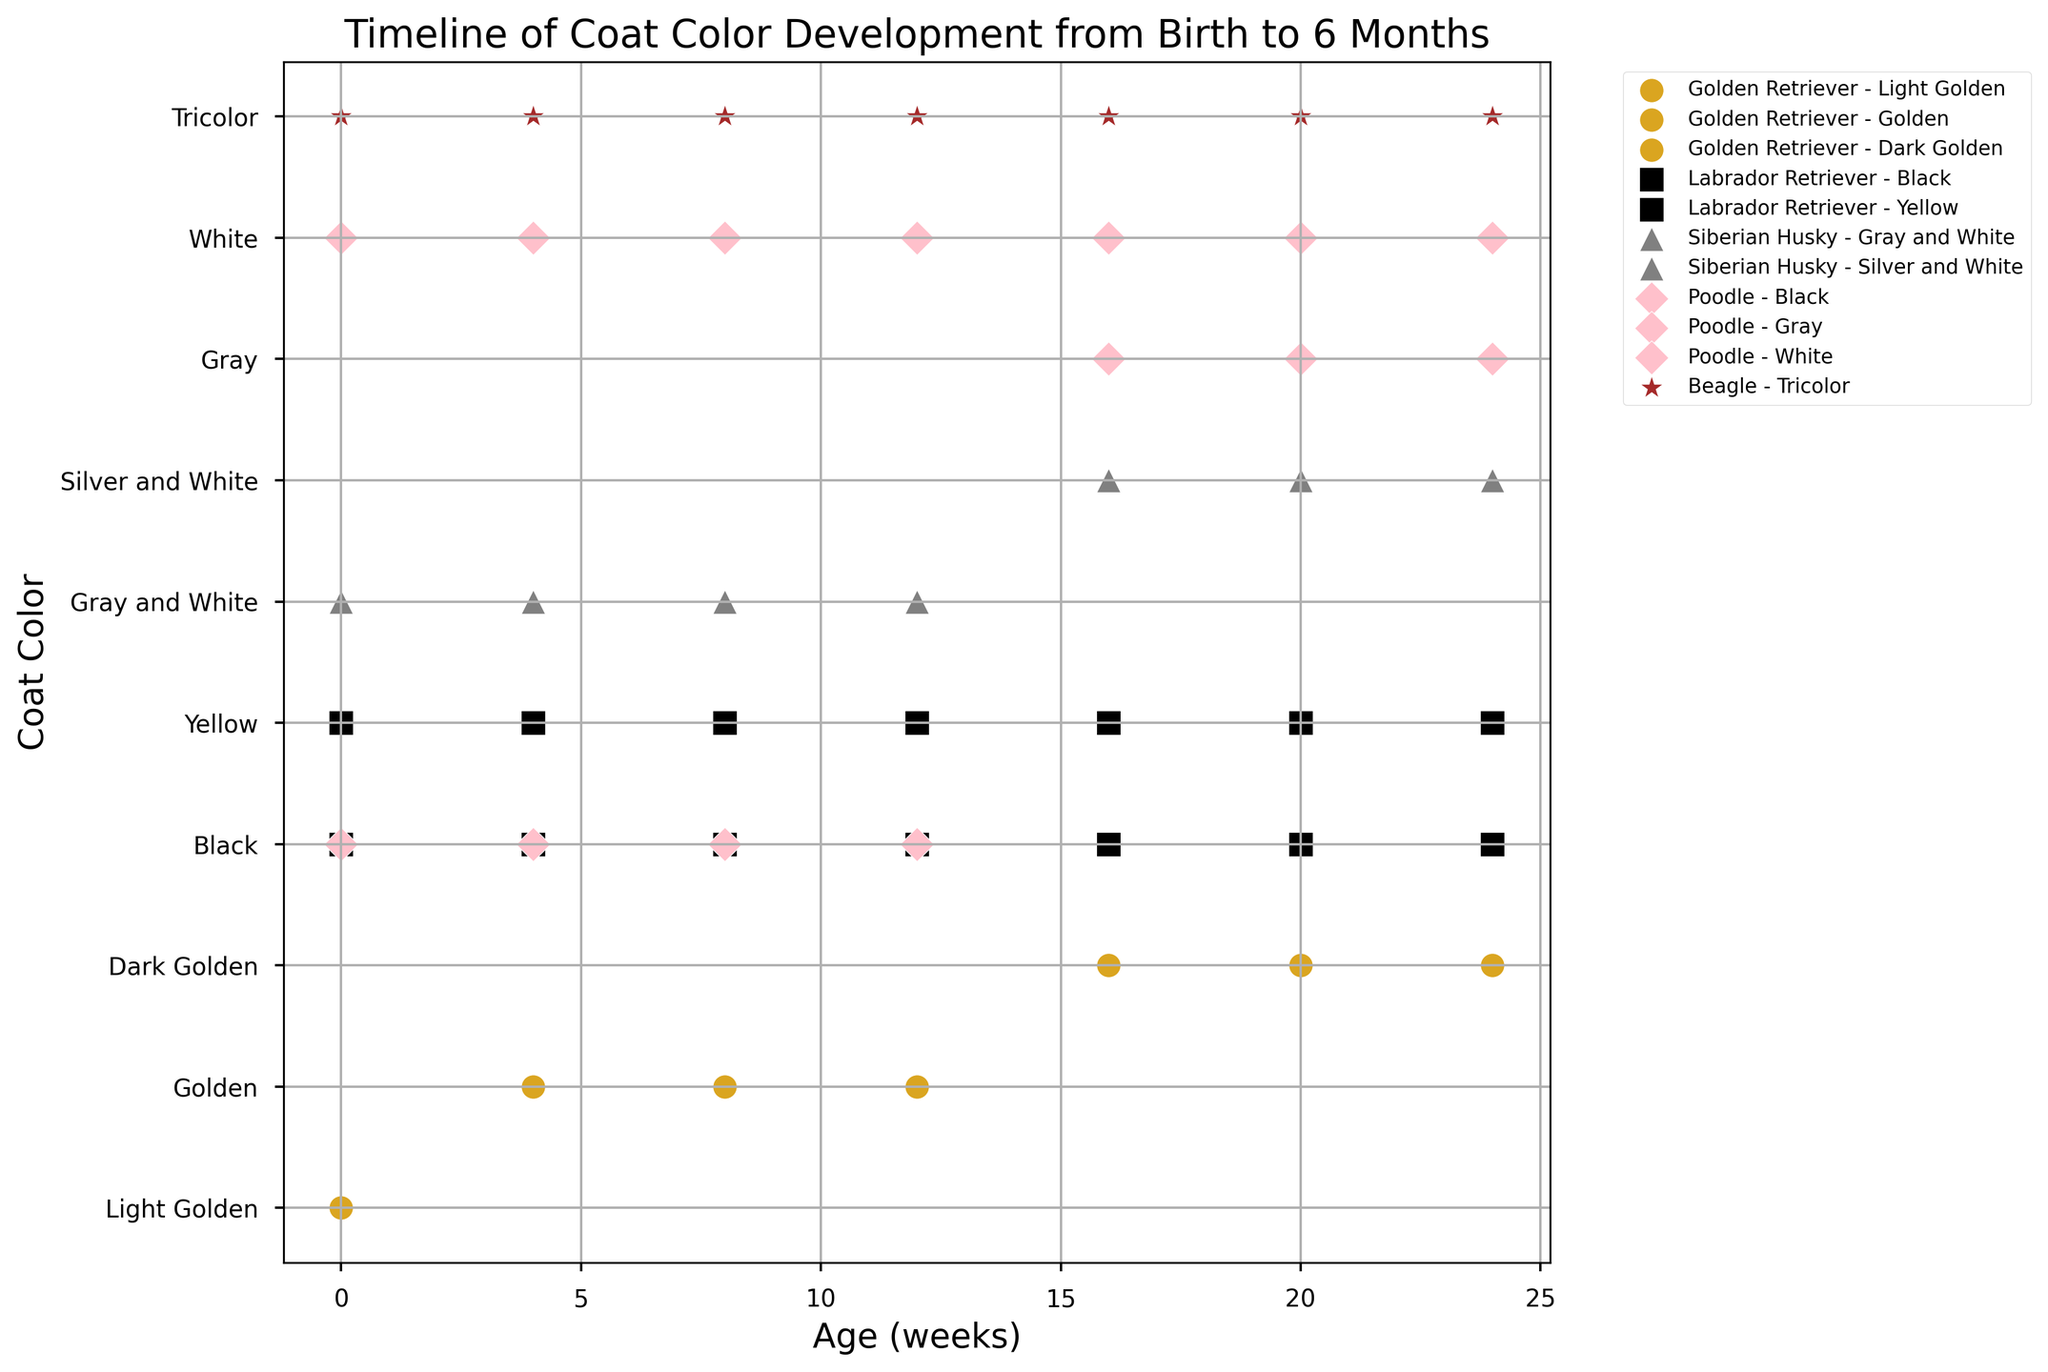Which breed has a coat color that changes from light to dark over time? Look at the plotted timeline. The Golden Retriever's coat color changes from Light Golden at birth to Dark Golden by 24 weeks.
Answer: Golden Retriever How many coat colors does the Labrador Retriever have at birth? Check the data points for the Labrador Retriever at 0 weeks. There are data points for both Black and Yellow coat colors.
Answer: 2 Which breed has a consistent coat color over the entire timeline? Check the plotted points for each breed throughout the timeline. The Beagle has a consistent Tricolor coat color from birth to 24 weeks.
Answer: Beagle At what age does the Poodle's coat color change from black to gray? Look at the Poodle's data points. The Poodle's coat color changes from Black to Gray at 16 weeks.
Answer: 16 weeks Which breed's coat color changes from Gray and White to Silver and White? Match the described color change with the plotted points. The Siberian Husky's coat color changes from Gray and White to Silver and White around 16 weeks.
Answer: Siberian Husky Compare the coat color changes of the Golden Retriever and the Siberian Husky. Which one has a more noticeable change? Both breeds show significant changes. The Golden Retriever changes from Light to Dark Golden, whereas the Siberian Husky changes from Gray and White to Silver and White. Assessing perceptual difference, Gold to Dark Golden seems more noticeable.
Answer: Golden Retriever How many breeds show a change in coat color during the observed timeline? Examine each breed's timeline for any changes. Golden Retriever, Siberian Husky, and Poodle show changes.
Answer: 3 What is the most common coat color for Labradors throughout the timeline? Count the occurrences of each coat color in the Labrador's data points. Both Black and Yellow appear equally frequently over the timeline.
Answer: Black and Yellow For the breeds that have coat color changes, how many distinct coat colors do they have by the end of the timeline? Identify the distinct coat colors at the 24-week mark for Golden Retriever, Siberian Husky, and Poodle. They each end up with different final colors: Dark Golden, Silver and White, and Gray respectively.
Answer: 3 Which breed has the fewest coat color changes? Check each breed's progression. Both Beagle and Labrador Retriever have no changes in coat color from birth to 24 weeks.
Answer: Beagle and Labrador Retriever 